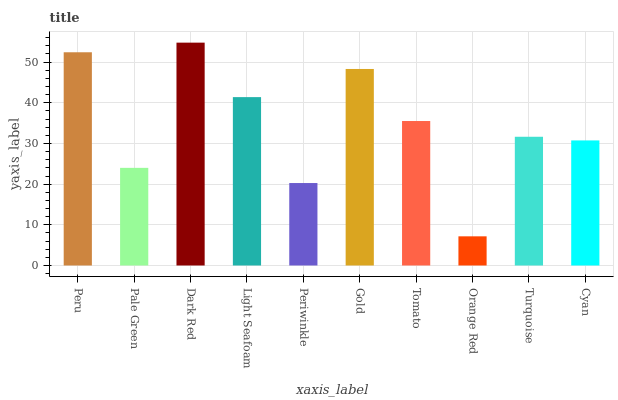Is Orange Red the minimum?
Answer yes or no. Yes. Is Dark Red the maximum?
Answer yes or no. Yes. Is Pale Green the minimum?
Answer yes or no. No. Is Pale Green the maximum?
Answer yes or no. No. Is Peru greater than Pale Green?
Answer yes or no. Yes. Is Pale Green less than Peru?
Answer yes or no. Yes. Is Pale Green greater than Peru?
Answer yes or no. No. Is Peru less than Pale Green?
Answer yes or no. No. Is Tomato the high median?
Answer yes or no. Yes. Is Turquoise the low median?
Answer yes or no. Yes. Is Light Seafoam the high median?
Answer yes or no. No. Is Periwinkle the low median?
Answer yes or no. No. 